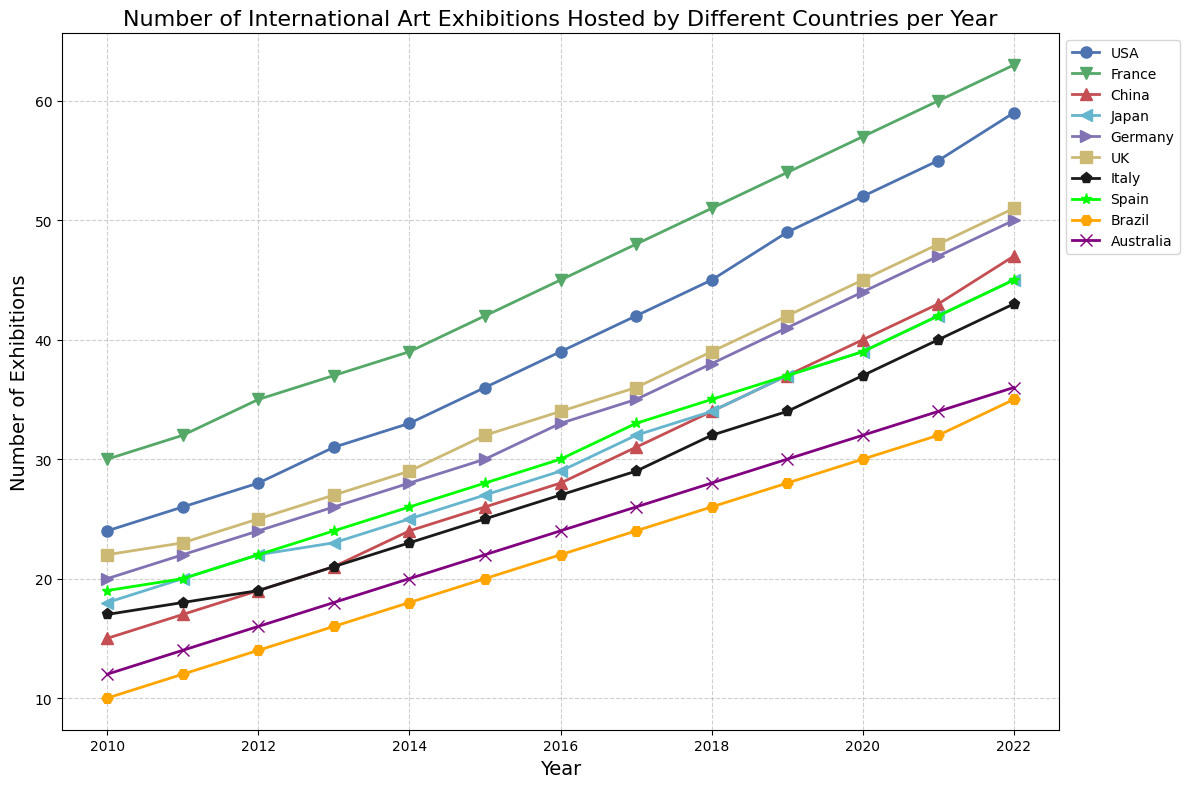What country hosted the most international art exhibitions in 2015? To determine which country hosted the most exhibitions in 2015, look at the data points for each country on the 2015 mark along the x-axis. The USA reaches the highest value at 36.
Answer: USA How did the number of exhibitions hosted by China change from 2010 to 2015? To find the change, look at the values for China in 2010 and 2015, which are 15 and 26, respectively. The change is 26 - 15 = 11.
Answer: Increased by 11 Which country showed the greatest increase in the number of exhibitions hosted from 2010 to 2022? Calculate the difference for each country between 2022 and 2010. The differences are: 
USA: (59 - 24) = 35,
France: (63 - 30) = 33,
China: (47 - 15) = 32,
Japan: (45 - 18) = 27,
Germany: (50 - 20) = 30,
UK: (51 - 22) = 29,
Italy: (43 - 17) = 26,
Spain: (45 - 19) = 26,
Brazil: (35 - 10) = 25,
Australia: (36 - 12) = 24.
The USA shows the greatest increase with 35.
Answer: USA In which year did France surpass 50 exhibitions for the first time? Look at the trend line for France and identify the first point above 50. The year is 2018.
Answer: 2018 What is the average number of exhibitions hosted by Japan from 2010 to 2022? Sum the number of exhibitions Japan hosted over the years (18 + 20 + 22 + 23 + 25 + 27 + 29 + 32 + 34 + 37 + 39 + 42 + 45) which equals 394. Then divide by the number of years (13). The average is 394 / 13 ≈ 30.31.
Answer: Approximately 30.31 Which country hosted fewer exhibitions than Italy in 2016? Identify the value for Italy in 2016 which is 27, then look for countries with values less than 27. For 2016, they are China (28), Brazil (22) and Australia (24). Therefore, only Brazil and Australia host fewer exhibitions than Italy.
Answer: Brazil, Australia How many exhibitions did the UK host in 2020 compared to 2010? Identify the values for the UK in 2020 (45) and 2010 (22), then calculate the difference 45 - 22 = 23.
Answer: 23 more exhibitions By how much did the number of exhibitions hosted by Spain increase between 2015 and 2017? Find the values for Spain in 2015 (28) and 2017 (33), then find the difference 33 - 28 = 5.
Answer: Increased by 5 Which country experienced a consistent increase in the number of exhibitions hosted every year from 2010 to 2022? Scan through each country's trend line to spot the one that consistently rises every year. France's line shows a consistent increase each year.
Answer: France 